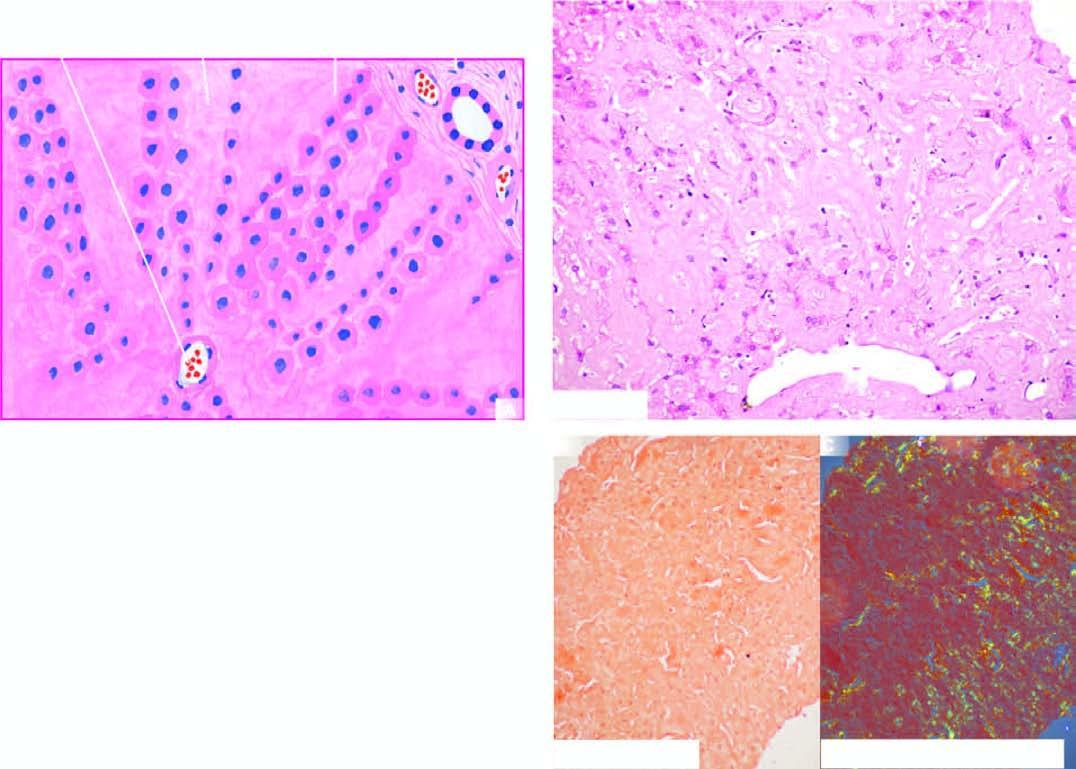s apple-green birefringence shown in this figure?
Answer the question using a single word or phrase. Yes 